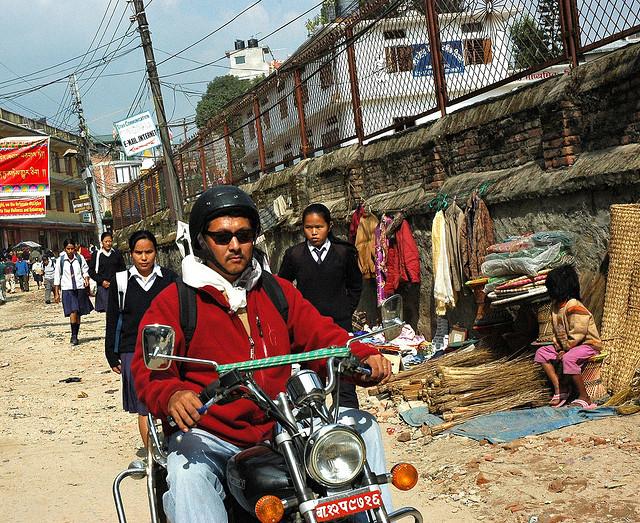What color is the second women's shirt?
Answer briefly. White. How many people are in the crowd?
Keep it brief. 10. Is the person happy?
Concise answer only. No. Where was this picture taken?
Keep it brief. City. Who is in red?
Give a very brief answer. Man. What is the man riding?
Keep it brief. Motorcycle. Are there school children wearing uniforms?
Short answer required. Yes. Are these people cold?
Quick response, please. No. 